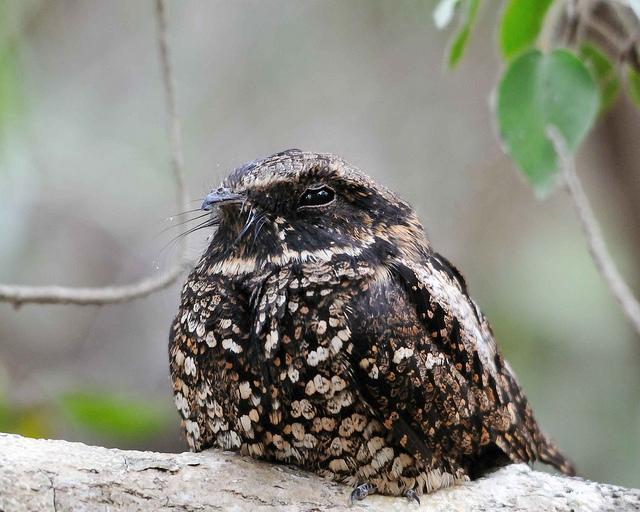How many people in this picture are carrying bags?
Give a very brief answer. 0. 